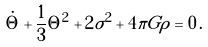<formula> <loc_0><loc_0><loc_500><loc_500>\dot { \Theta } + \frac { 1 } { 3 } \Theta ^ { 2 } + 2 \sigma ^ { 2 } + 4 \pi G \rho = 0 \, .</formula> 